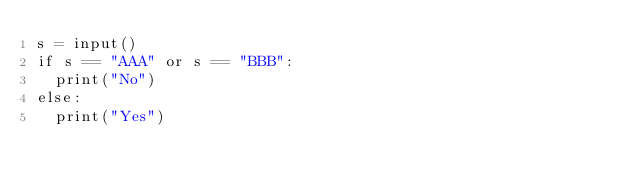<code> <loc_0><loc_0><loc_500><loc_500><_Python_>s = input()
if s == "AAA" or s == "BBB":
  print("No")
else:
  print("Yes")</code> 